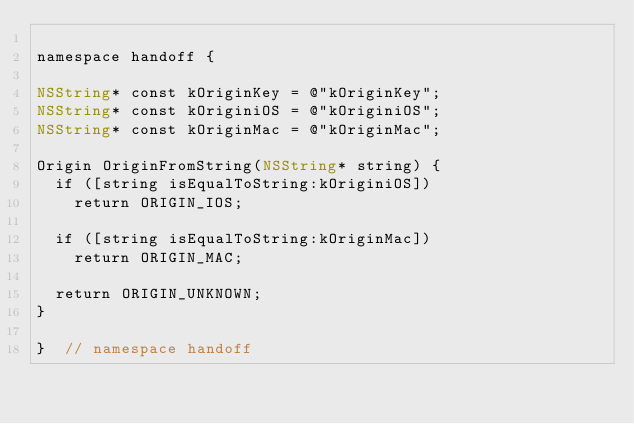<code> <loc_0><loc_0><loc_500><loc_500><_ObjectiveC_>
namespace handoff {

NSString* const kOriginKey = @"kOriginKey";
NSString* const kOriginiOS = @"kOriginiOS";
NSString* const kOriginMac = @"kOriginMac";

Origin OriginFromString(NSString* string) {
  if ([string isEqualToString:kOriginiOS])
    return ORIGIN_IOS;

  if ([string isEqualToString:kOriginMac])
    return ORIGIN_MAC;

  return ORIGIN_UNKNOWN;
}

}  // namespace handoff
</code> 